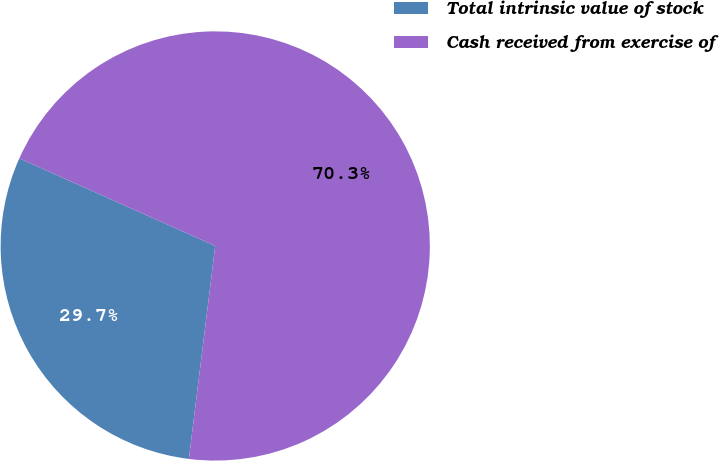<chart> <loc_0><loc_0><loc_500><loc_500><pie_chart><fcel>Total intrinsic value of stock<fcel>Cash received from exercise of<nl><fcel>29.73%<fcel>70.27%<nl></chart> 